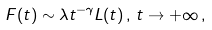<formula> <loc_0><loc_0><loc_500><loc_500>F ( t ) \sim \lambda t ^ { - \gamma } L ( t ) \, , \, t \rightarrow + \infty \, ,</formula> 